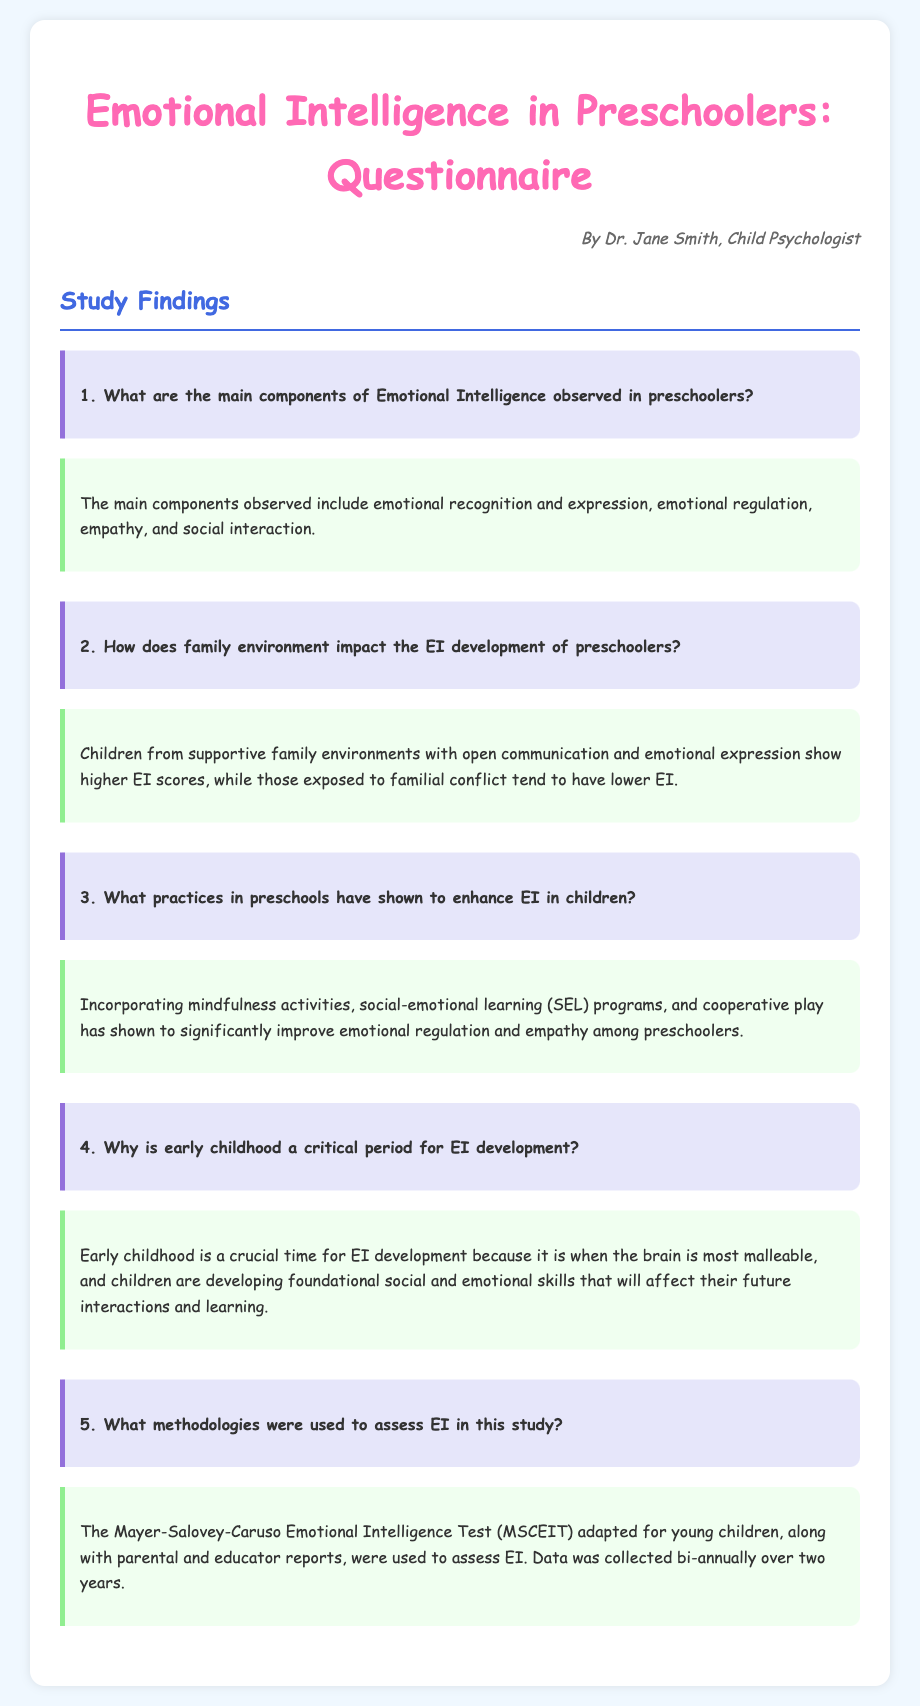What are the main components of Emotional Intelligence? The main components include emotional recognition and expression, emotional regulation, empathy, and social interaction as stated in the findings section.
Answer: emotional recognition and expression, emotional regulation, empathy, social interaction How does family environment impact EI development? The document states that supportive family environments correlate with higher EI scores, while familial conflict correlates with lower EI.
Answer: supportive family environments What practices in preschools enhance EI? It mentions incorporating mindfulness activities, social-emotional learning programs, and cooperative play as significant practices to improve EI in preschoolers.
Answer: mindfulness activities, social-emotional learning programs, cooperative play Why is early childhood critical for EI development? The document explains that early childhood is crucial because the brain is most malleable during this period, affecting future interactions and learning.
Answer: brain is most malleable What methodologies assessed EI in this study? It specifies that the Mayer-Salovey-Caruso Emotional Intelligence Test adapted for young children and parental and educator reports were used.
Answer: MSCEIT, parental and educator reports Who authored the questionnaire? The name of the author is mentioned at the beginning of the document, indicating who created the questionnaire.
Answer: Dr. Jane Smith 